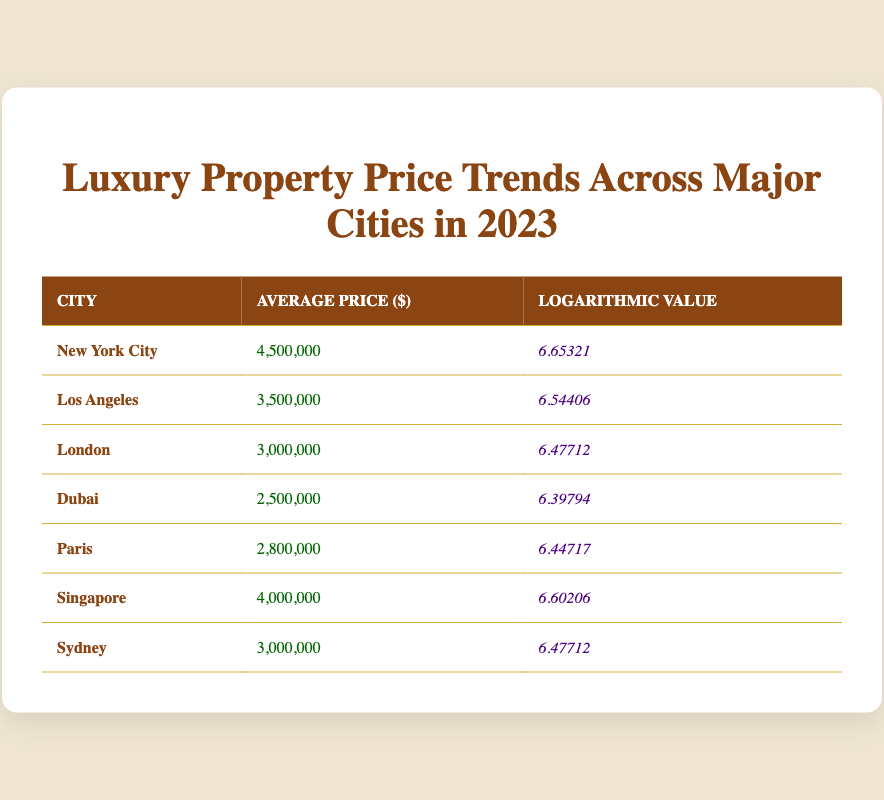What is the average price of luxury properties in New York City? The table lists New York City's average price as $4,500,000. Therefore, the answer is obtained directly from the table without any calculation.
Answer: 4,500,000 Which city has the highest logarithmic value? By examining the logarithmic values, New York City has the highest value at 6.65321, confirming it as the city with the top logarithmic score directly from the table.
Answer: New York City What is the average price difference between Los Angeles and Dubai? The average price in Los Angeles is $3,500,000, while in Dubai it is $2,500,000. The difference is calculated as 3,500,000 - 2,500,000 = $1,000,000.
Answer: 1,000,000 Is the average price of luxury properties in Paris higher than in London? The average price in Paris is $2,800,000, while in London it is $3,000,000. Therefore, comparing these two values shows that Paris's price is lower than London's.
Answer: No What are the average prices of luxury properties in cities with logarithmic values higher than 6.5? The cities with logarithmic values over 6.5 are New York City (4,500,000), Singapore (4,000,000), and Los Angeles (3,500,000). To get the prices, list those three directly from the table: 4,500,000; 4,000,000; 3,500,000.
Answer: 4,500,000; 4,000,000; 3,500,000 Which city has the lowest average price among the listed cities, and what is that price? By scanning the average prices, Dubai has the lowest price at $2,500,000. This is the minimum value when comparing all prices directly from the table.
Answer: 2,500,000 What is the median average price of luxury properties in this data? To find the median, we first list prices in ascending order: 2,500,000; 2,800,000; 3,000,000; 3,000,000; 3,500,000; 4,000,000; 4,500,000. With seven values, the median (middle one) is the fourth value, which is $3,000,000.
Answer: 3,000,000 Is the average price of luxury properties in Sydney equal to that in London? The average price in Sydney is $3,000,000, which matches exactly with London’s average price also being $3,000,000. Thus, both are the same amount.
Answer: Yes 